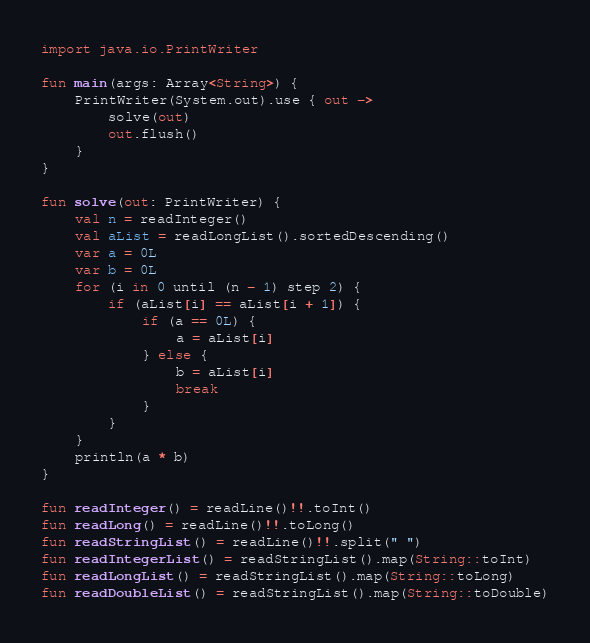Convert code to text. <code><loc_0><loc_0><loc_500><loc_500><_Kotlin_>import java.io.PrintWriter

fun main(args: Array<String>) {
    PrintWriter(System.out).use { out ->
        solve(out)
        out.flush()
    }
}

fun solve(out: PrintWriter) {
    val n = readInteger()
    val aList = readLongList().sortedDescending()
    var a = 0L
    var b = 0L
    for (i in 0 until (n - 1) step 2) {
        if (aList[i] == aList[i + 1]) {
            if (a == 0L) {
                a = aList[i]
            } else {
                b = aList[i]
                break
            }
        }
    }
    println(a * b)
}

fun readInteger() = readLine()!!.toInt()
fun readLong() = readLine()!!.toLong()
fun readStringList() = readLine()!!.split(" ")
fun readIntegerList() = readStringList().map(String::toInt)
fun readLongList() = readStringList().map(String::toLong)
fun readDoubleList() = readStringList().map(String::toDouble)
</code> 